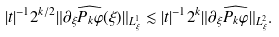<formula> <loc_0><loc_0><loc_500><loc_500>| t | ^ { - 1 } 2 ^ { k / 2 } \| \partial _ { \xi } \widehat { P _ { k } \varphi } ( \xi ) \| _ { L _ { \xi } ^ { 1 } } \lesssim | t | ^ { - 1 } 2 ^ { k } \| \partial _ { \xi } \widehat { P _ { k } \varphi } \| _ { L _ { \xi } ^ { 2 } } .</formula> 